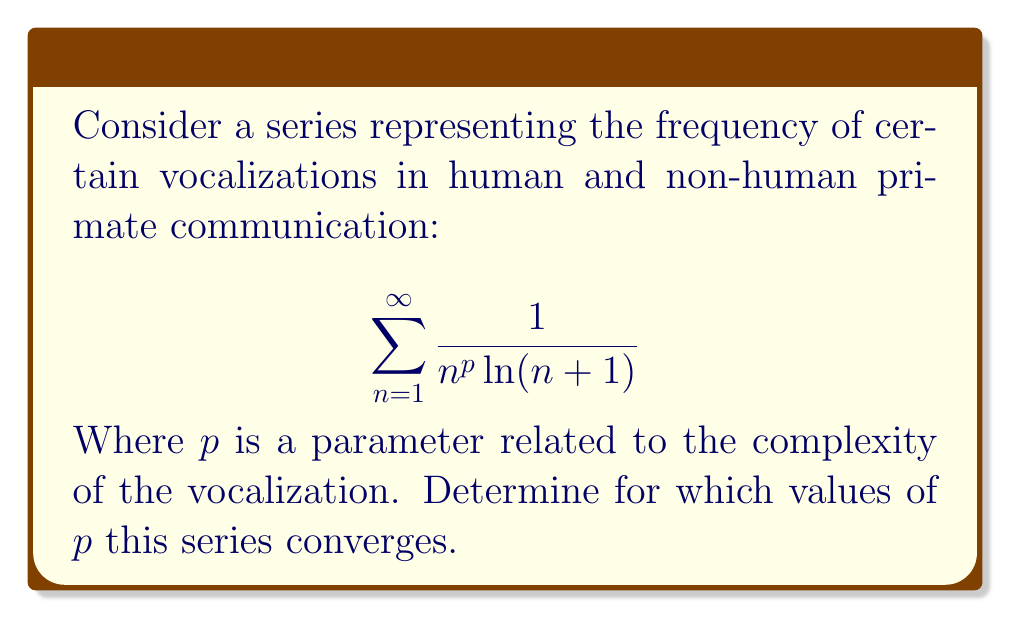Provide a solution to this math problem. To analyze the convergence of this series, we'll use the integral test and compare it with p-series.

1) First, let's consider the function $f(x) = \frac{1}{x^p \ln(x+1)}$.

2) For the integral test, we need to evaluate:

   $$\int_1^{\infty} \frac{1}{x^p \ln(x+1)} dx$$

3) This integral converges if and only if our original series converges.

4) Let's compare our series with the p-series $\sum_{n=1}^{\infty} \frac{1}{n^q}$:

   $$\frac{1}{n^p \ln(n+1)} \geq \frac{1}{n^p \ln(n+1)} \cdot \frac{\ln(n+1)}{\ln(n+1)} = \frac{1}{n^p}$$

5) Therefore, if our series converges, it must converge for all $p > 1$, as this is the convergence condition for p-series.

6) Now, let's compare with a series that converges for $p > 1$:

   $$\frac{1}{n^p \ln(n+1)} \leq \frac{1}{n^p} \cdot \frac{1}{\ln 2} \quad \text{(since } \ln(n+1) \geq \ln 2 \text{ for } n \geq 1)$$

7) This shows that our series converges for all $p > 1$.

8) For $p \leq 1$, we can show divergence:

   $$\frac{1}{n^p \ln(n+1)} \geq \frac{1}{n \ln(n+1)}$$

   The right-hand side is the general harmonic series, which diverges.

Therefore, the series converges for $p > 1$ and diverges for $p \leq 1$.
Answer: The series $\sum_{n=1}^{\infty} \frac{1}{n^p \ln(n+1)}$ converges for $p > 1$ and diverges for $p \leq 1$. 